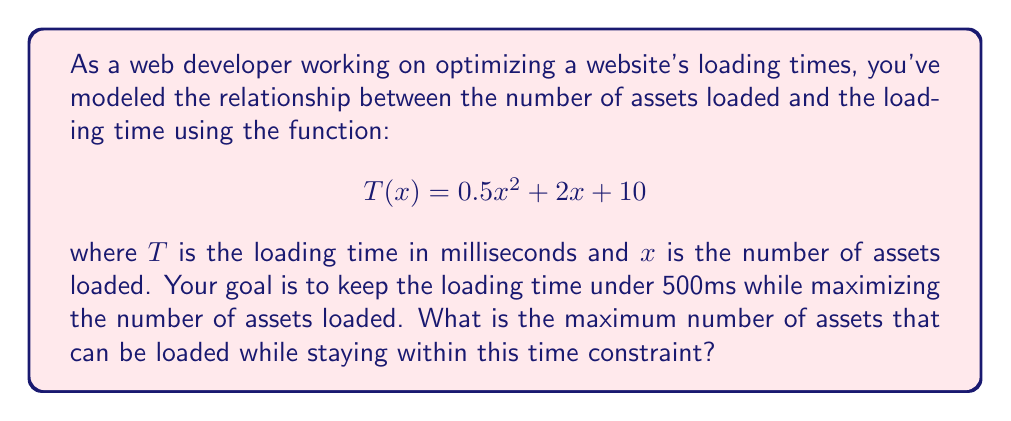Solve this math problem. To solve this problem, we need to follow these steps:

1) We want to find the maximum value of $x$ such that $T(x) \leq 500$.

2) This gives us the inequality:
   $$0.5x^2 + 2x + 10 \leq 500$$

3) Rearranging the terms:
   $$0.5x^2 + 2x - 490 \leq 0$$

4) This is a quadratic inequality. To solve it, we first need to find the roots of the corresponding quadratic equation:
   $$0.5x^2 + 2x - 490 = 0$$

5) We can solve this using the quadratic formula: $x = \frac{-b \pm \sqrt{b^2 - 4ac}}{2a}$

   Where $a = 0.5$, $b = 2$, and $c = -490$

6) Plugging these values into the quadratic formula:

   $$x = \frac{-2 \pm \sqrt{2^2 - 4(0.5)(-490)}}{2(0.5)}$$
   $$= \frac{-2 \pm \sqrt{4 + 980}}{1}$$
   $$= \frac{-2 \pm \sqrt{984}}{1}$$
   $$= -2 \pm 31.37$$

7) This gives us two roots: $x_1 \approx 29.37$ and $x_2 \approx -33.37$

8) Since we're dealing with the number of assets, we're only interested in positive values. Therefore, the solution to our inequality is:

   $$0 \leq x \leq 29.37$$

9) As we're looking for the maximum number of assets, which must be a whole number, we round down to 29.
Answer: The maximum number of assets that can be loaded while keeping the loading time under 500ms is 29. 